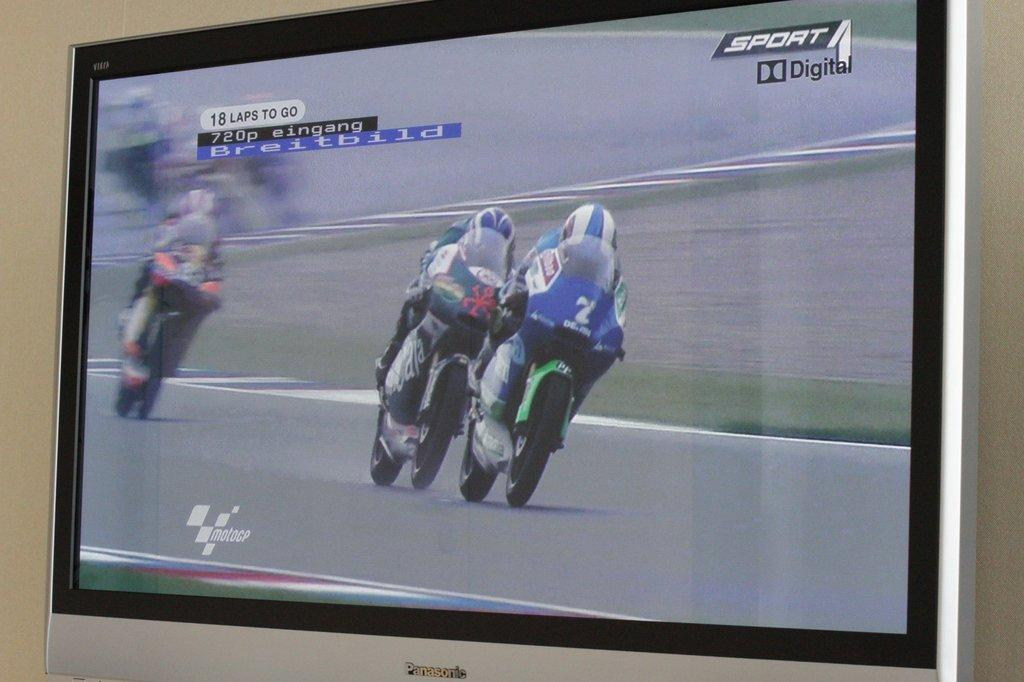What is happening on the screen of the television in the image? There are persons riding a bike on the screen of a television. What can be seen in the background of the image? There is a wall in the background of the image. How many passengers are on the bike in the image? There is no bike present in the image; it is a television screen showing persons riding a bike. 